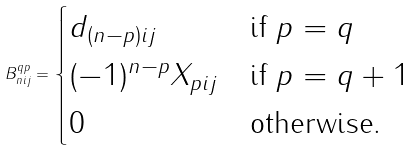Convert formula to latex. <formula><loc_0><loc_0><loc_500><loc_500>B _ { n i j } ^ { q p } = \begin{cases} d _ { ( n - p ) i j } & \text {if $p=q$} \\ ( - 1 ) ^ { n - p } X _ { p i j } & \text {if $p=q+1$} \\ 0 & \text {otherwise.} \end{cases}</formula> 